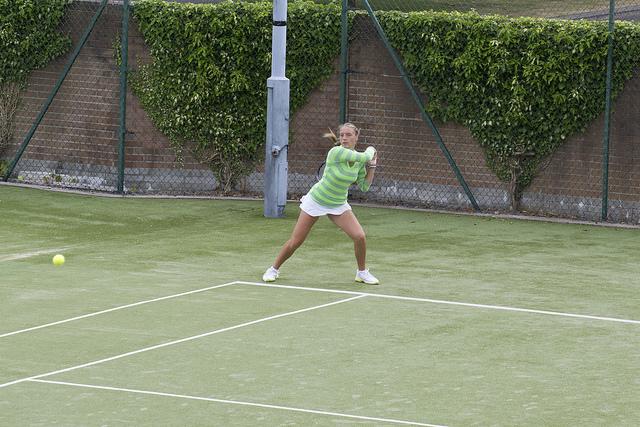What sport is she playing?
Be succinct. Tennis. Is the girl wearing green?
Write a very short answer. Yes. What type of fence is in the picture?
Concise answer only. Chain link. 